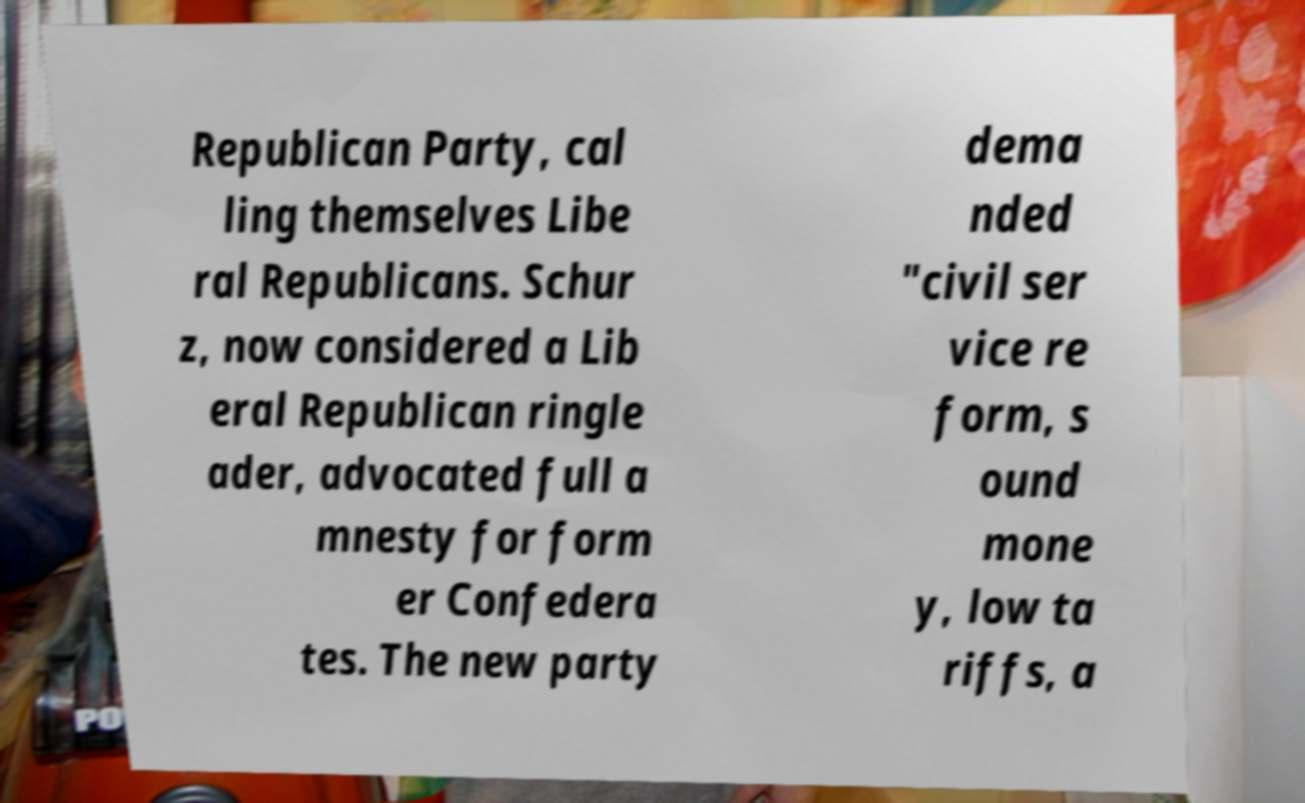Could you extract and type out the text from this image? Republican Party, cal ling themselves Libe ral Republicans. Schur z, now considered a Lib eral Republican ringle ader, advocated full a mnesty for form er Confedera tes. The new party dema nded "civil ser vice re form, s ound mone y, low ta riffs, a 